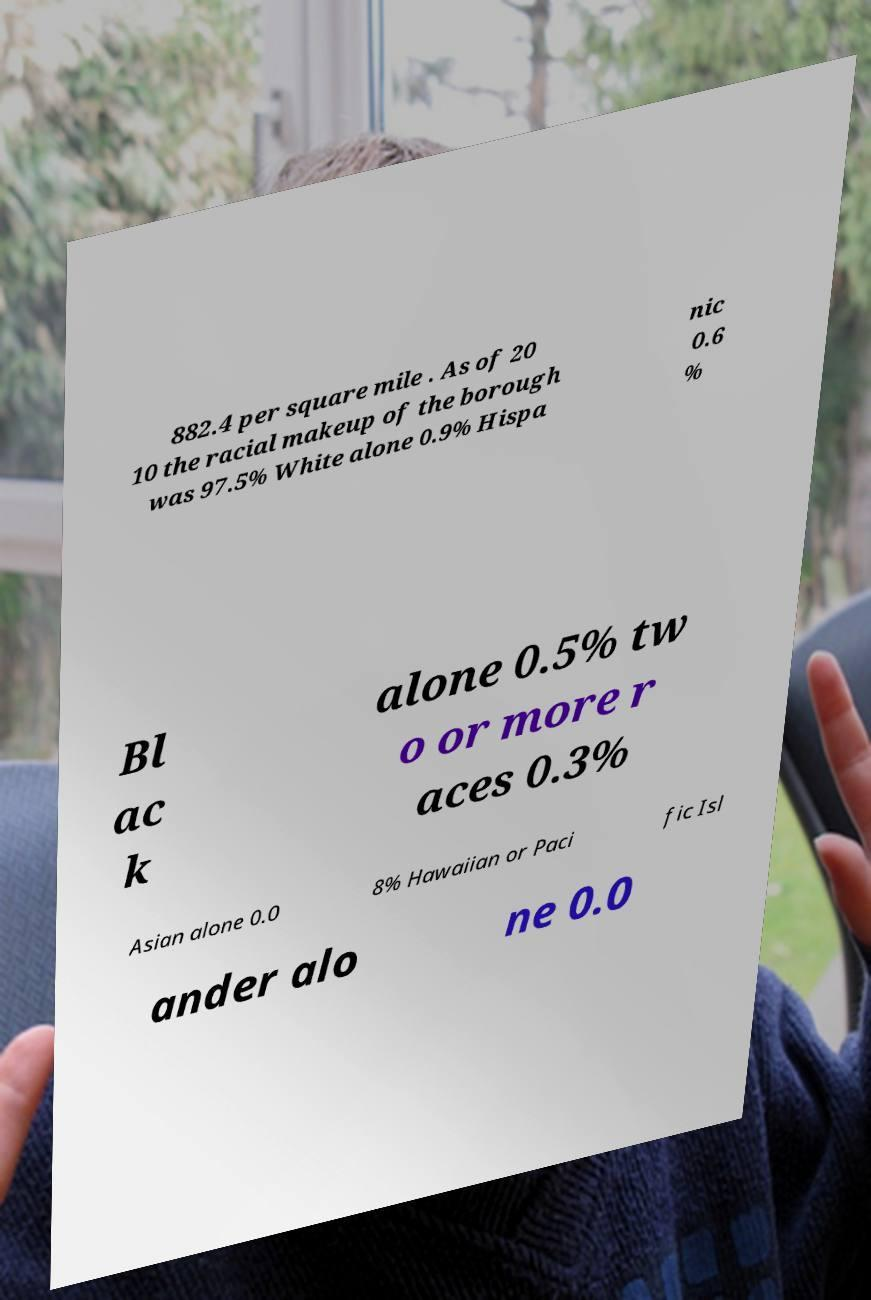Please identify and transcribe the text found in this image. 882.4 per square mile . As of 20 10 the racial makeup of the borough was 97.5% White alone 0.9% Hispa nic 0.6 % Bl ac k alone 0.5% tw o or more r aces 0.3% Asian alone 0.0 8% Hawaiian or Paci fic Isl ander alo ne 0.0 